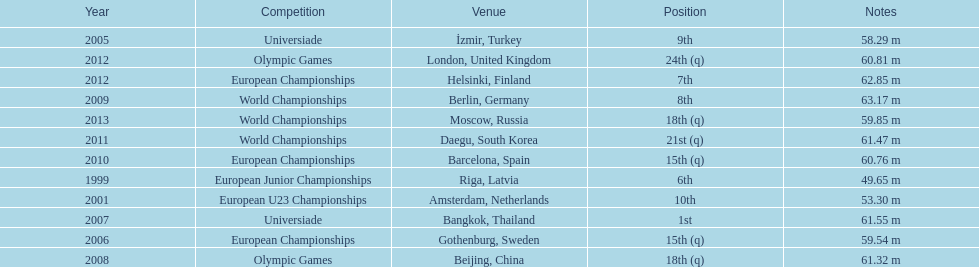Which year held the most competitions? 2012. 